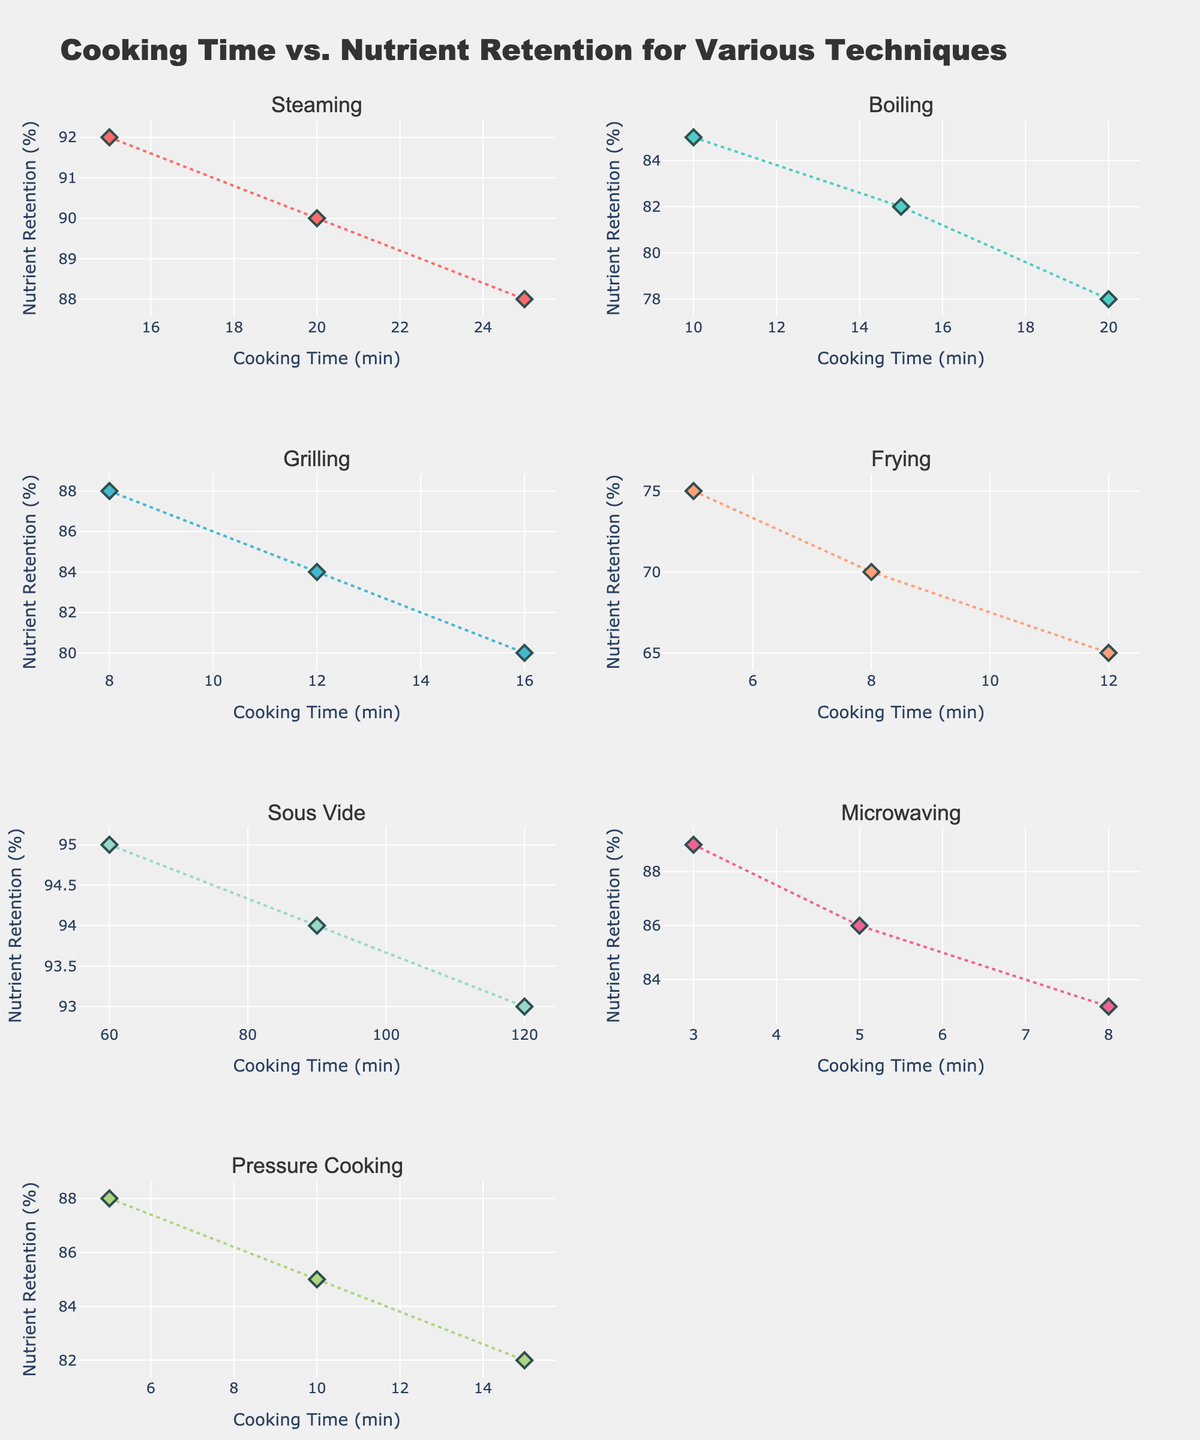How many culinary techniques are displayed in the figure? The subplot titles indicate the number of different culinary techniques. In this case, there are titles for Steaming, Boiling, Grilling, Frying, Sous Vide, Microwaving, and Pressure Cooking.
Answer: 7 Which culinary technique has the highest nutrient retention at the longest cooking time? By examining the plots, we see that Sous Vide retains the highest nutrients at the maximum cooking time, with a retention of 93% at 120 minutes.
Answer: Sous Vide Which technique shows the fastest decline in nutrient retention with increasing cooking time? By observing the slope of each line in the scatter plots, we note that Frying shows the steepest decline, indicating a rapid decrease in nutrient retention as cooking time increases.
Answer: Frying What is the average nutrient retention for the Boiling technique? Boiling has data points with nutrient retentions of 85%, 82%, and 78%. Summing these (85 + 82 + 78) = 245 and dividing by the number of data points (3), we get 245 / 3 = 81.67.
Answer: 81.67 Which technique retains more nutrients at 10 minutes of cooking time, Boiling or Pressure Cooking? By referencing the plots, Boiling retains 85% while Pressure Cooking retains 88% at 10 minutes. Hence, Pressure Cooking retains more nutrients.
Answer: Pressure Cooking Compare the nutrient retention between Steaming and Grilling at 20 minutes of cooking time. Which retains more? At 20 minutes, Steaming retains 90% nutrients while Grilling retains approximately 80%. Thus, Steaming retains more nutrients.
Answer: Steaming Find the cooking time with the highest nutrient retention for Grilling. What is the nutrient retention percentage? For Grilling, the highest nutrient retention occurs at the shortest cooking time, which is 88% at 8 minutes.
Answer: 88% Across all techniques, what is the highest percentage of nutrient retention observed and the corresponding technique? By looking at all plots, the highest nutrient retention is 95%, observed in Sous Vide.
Answer: 95%, Sous Vide What is the difference in nutrient retention between Microwaving and Frying at their shortest cooking times? Microwaving at 3 minutes retains 89% while Frying at 5 minutes retains 75%. The difference is 89% - 75% = 14%.
Answer: 14% Which technique has the least variation in nutrient retention across its cooking times? By inspecting the spread of data points in each plot, Sous Vide has the smallest range of nutrient retention values (from 93% to 95%).
Answer: Sous Vide 